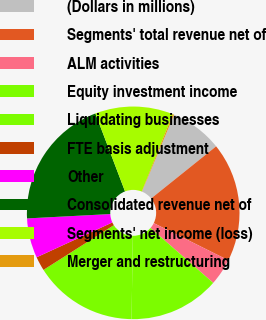Convert chart. <chart><loc_0><loc_0><loc_500><loc_500><pie_chart><fcel>(Dollars in millions)<fcel>Segments' total revenue net of<fcel>ALM activities<fcel>Equity investment income<fcel>Liquidating businesses<fcel>FTE basis adjustment<fcel>Other<fcel>Consolidated revenue net of<fcel>Segments' net income (loss)<fcel>Merger and restructuring<nl><fcel>7.97%<fcel>18.11%<fcel>4.09%<fcel>13.8%<fcel>15.74%<fcel>2.15%<fcel>6.03%<fcel>20.05%<fcel>11.86%<fcel>0.2%<nl></chart> 